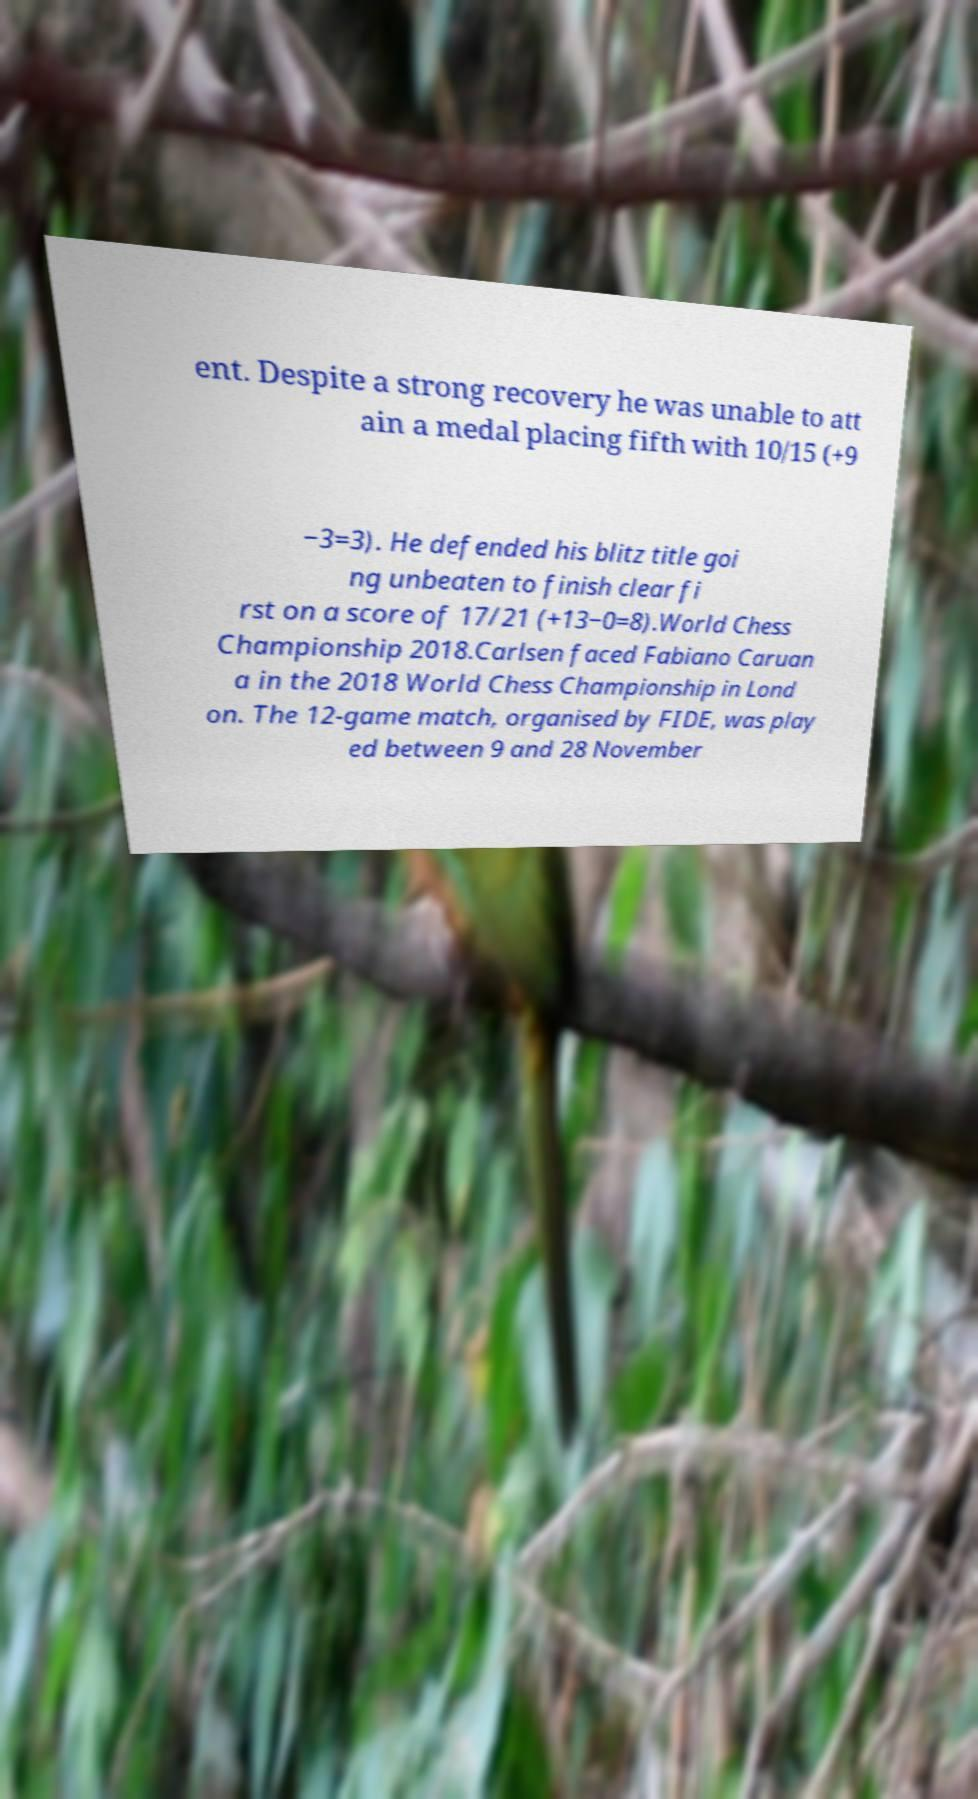Can you accurately transcribe the text from the provided image for me? ent. Despite a strong recovery he was unable to att ain a medal placing fifth with 10/15 (+9 −3=3). He defended his blitz title goi ng unbeaten to finish clear fi rst on a score of 17/21 (+13−0=8).World Chess Championship 2018.Carlsen faced Fabiano Caruan a in the 2018 World Chess Championship in Lond on. The 12-game match, organised by FIDE, was play ed between 9 and 28 November 